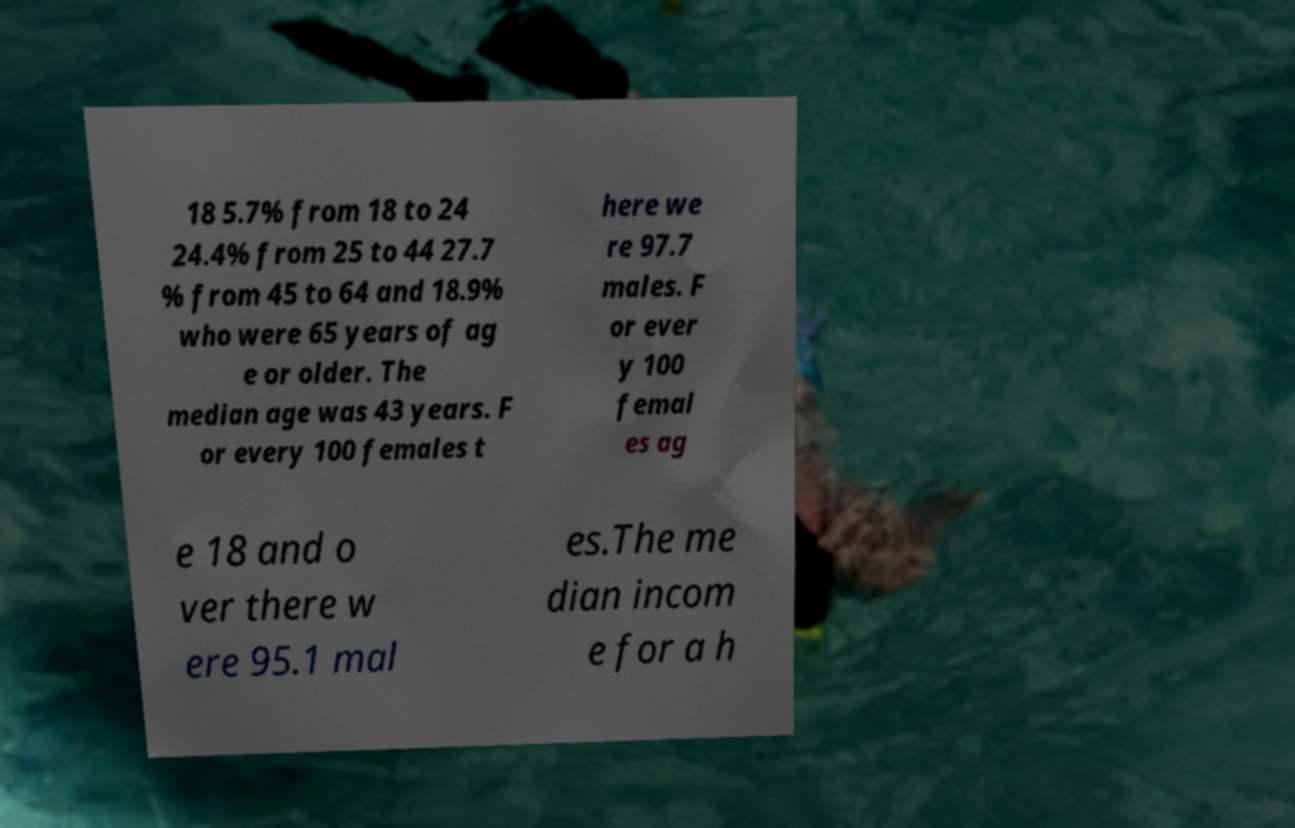Could you extract and type out the text from this image? 18 5.7% from 18 to 24 24.4% from 25 to 44 27.7 % from 45 to 64 and 18.9% who were 65 years of ag e or older. The median age was 43 years. F or every 100 females t here we re 97.7 males. F or ever y 100 femal es ag e 18 and o ver there w ere 95.1 mal es.The me dian incom e for a h 